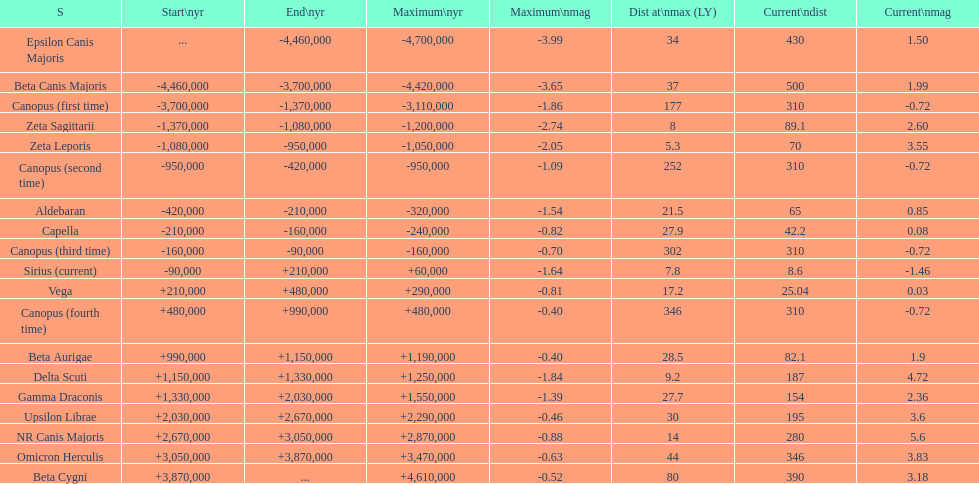How many stars do not have a current magnitude greater than zero? 5. 